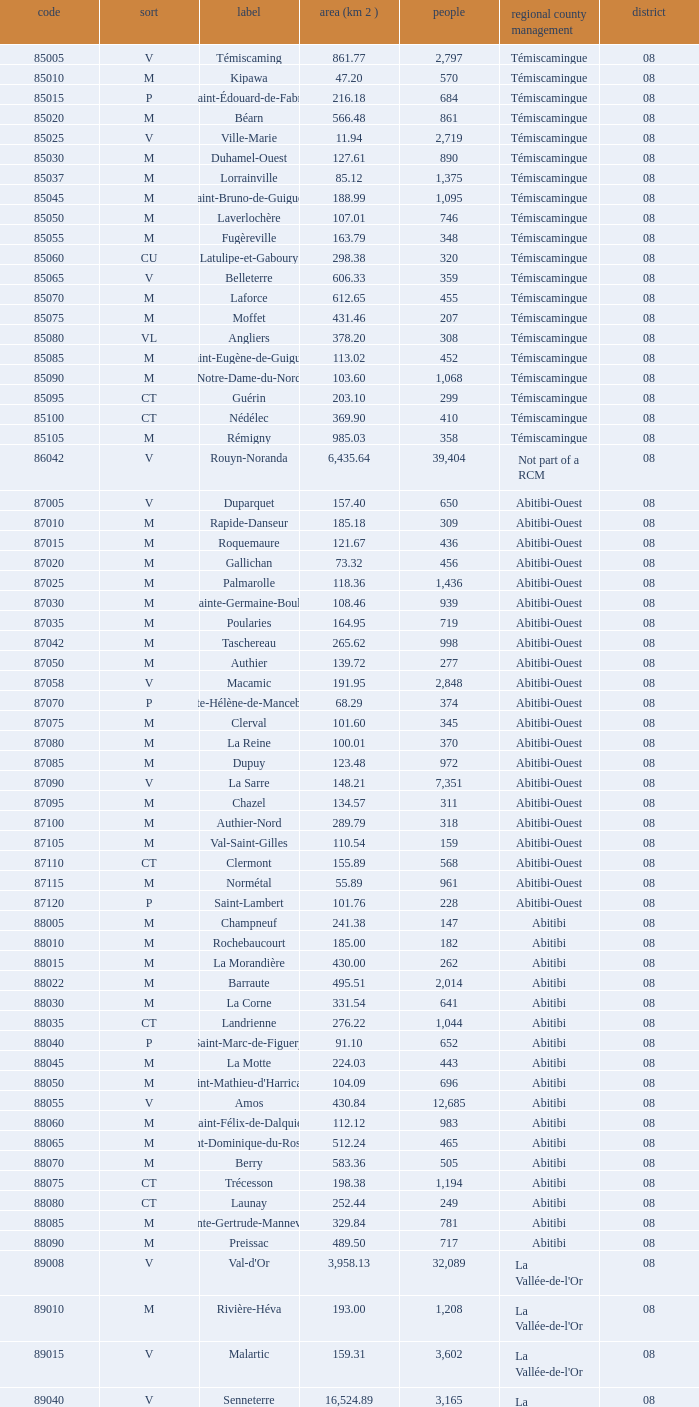What type has a population of 370? M. 